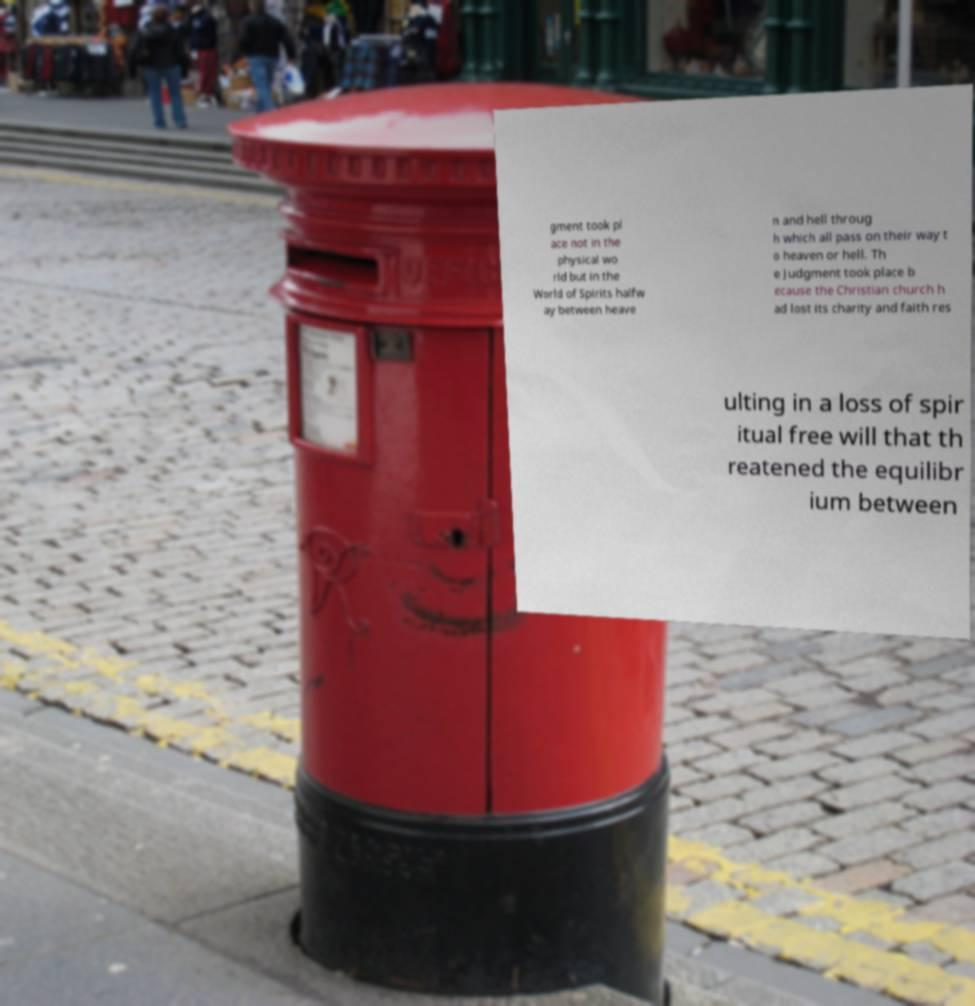Please identify and transcribe the text found in this image. gment took pl ace not in the physical wo rld but in the World of Spirits halfw ay between heave n and hell throug h which all pass on their way t o heaven or hell. Th e Judgment took place b ecause the Christian church h ad lost its charity and faith res ulting in a loss of spir itual free will that th reatened the equilibr ium between 